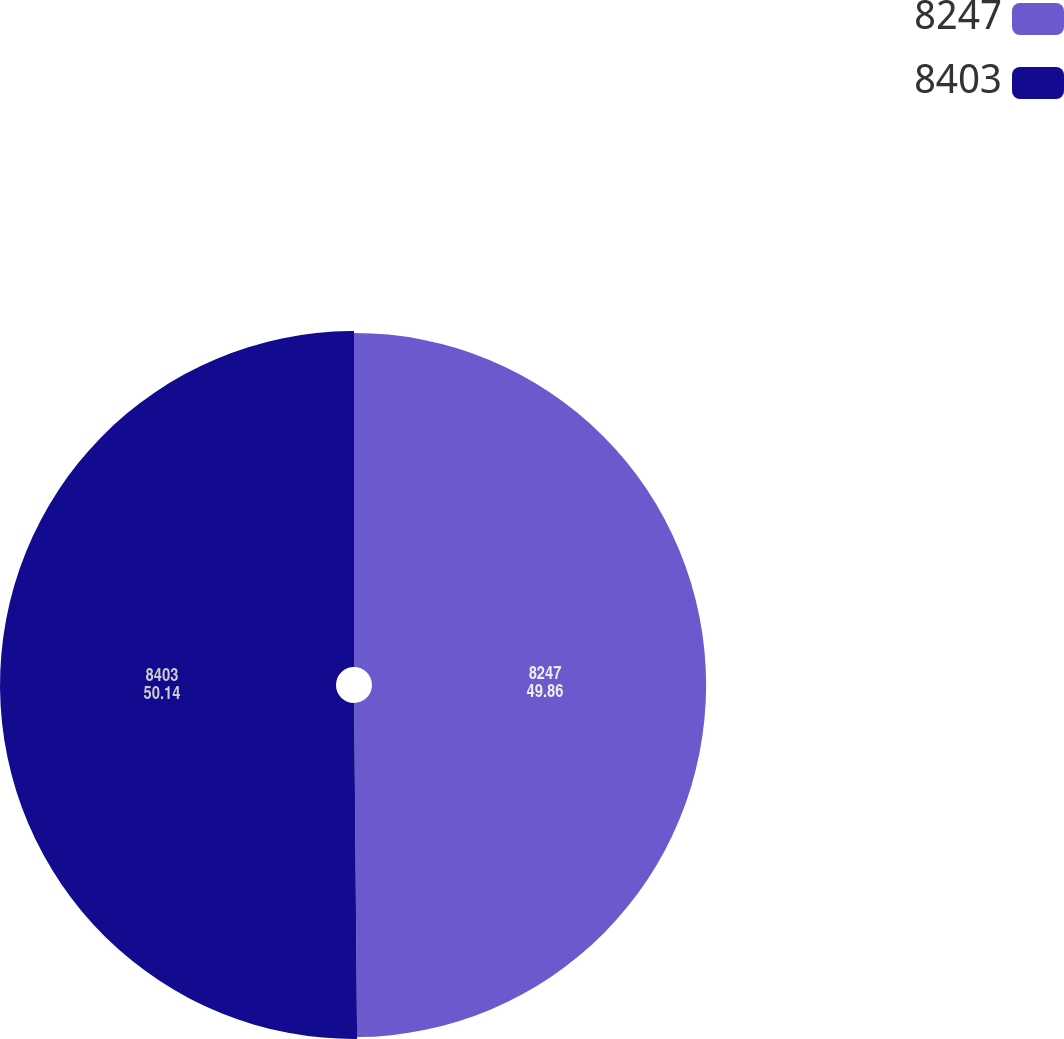<chart> <loc_0><loc_0><loc_500><loc_500><pie_chart><fcel>8247<fcel>8403<nl><fcel>49.86%<fcel>50.14%<nl></chart> 